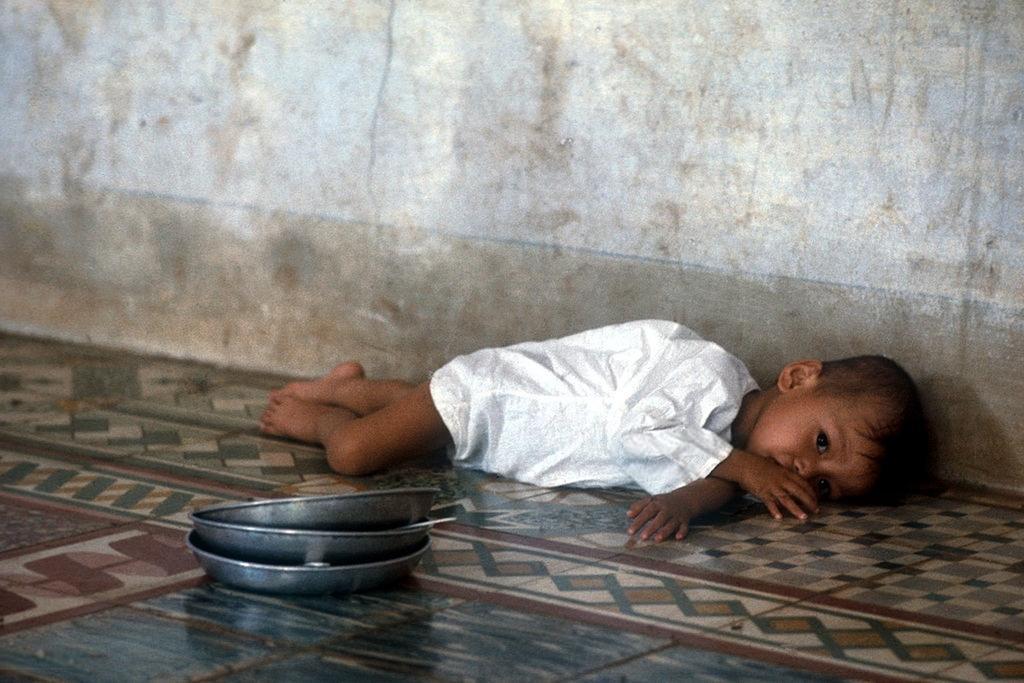Please provide a concise description of this image. In this image we can see a child wearing white dress lying on the floor. In the foreground we can see a group of plates placed on the floor. 